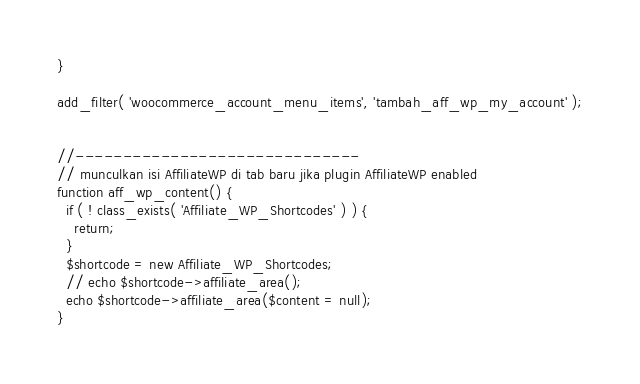Convert code to text. <code><loc_0><loc_0><loc_500><loc_500><_PHP_>}

add_filter( 'woocommerce_account_menu_items', 'tambah_aff_wp_my_account' );


//------------------------------
// munculkan isi AffiliateWP di tab baru jika plugin AffiliateWP enabled
function aff_wp_content() {
  if ( ! class_exists( 'Affiliate_WP_Shortcodes' ) ) {
    return;
  }
  $shortcode = new Affiliate_WP_Shortcodes;
  // echo $shortcode->affiliate_area();
  echo $shortcode->affiliate_area($content = null);
}
</code> 